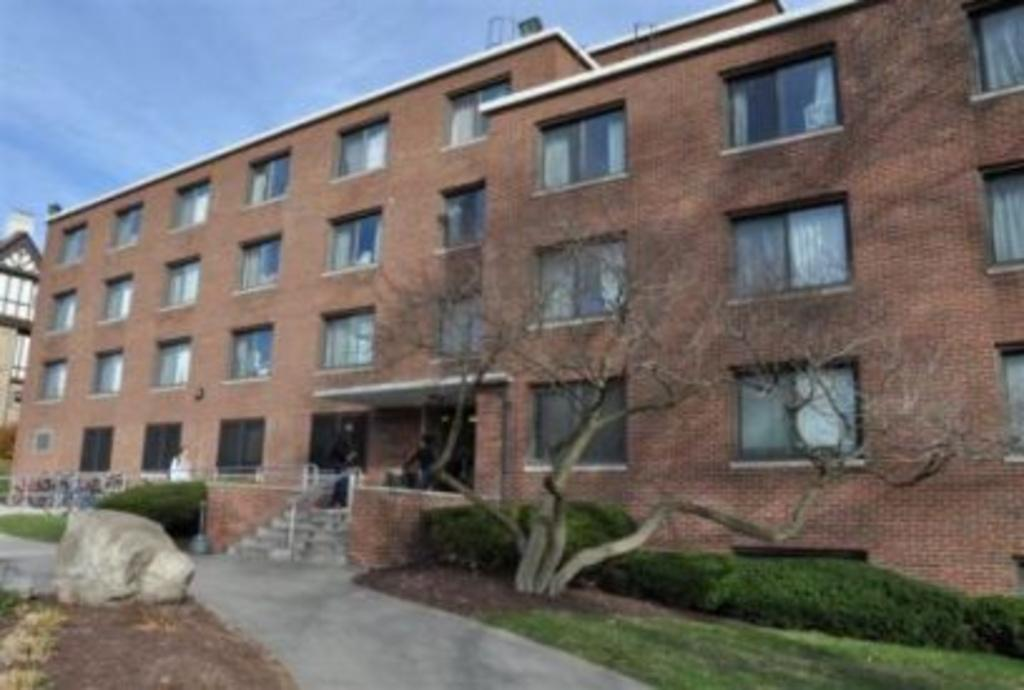What type of structures can be seen in the image? There are buildings in the image. What type of vegetation is present in the image? There are trees, plants, and grass in the image. What is the natural element visible in the image? There is a rock in the image. Are there any architectural features in the image? Yes, there are stairs in the image. What can be seen in the buildings in the image? There are windows in the buildings in the image. What part of the natural environment is visible in the image? The sky is visible in the image. What type of toys can be seen on the stage in the image? There is no stage or toys present in the image. What does the caption say about the image? There is no caption present in the image. 